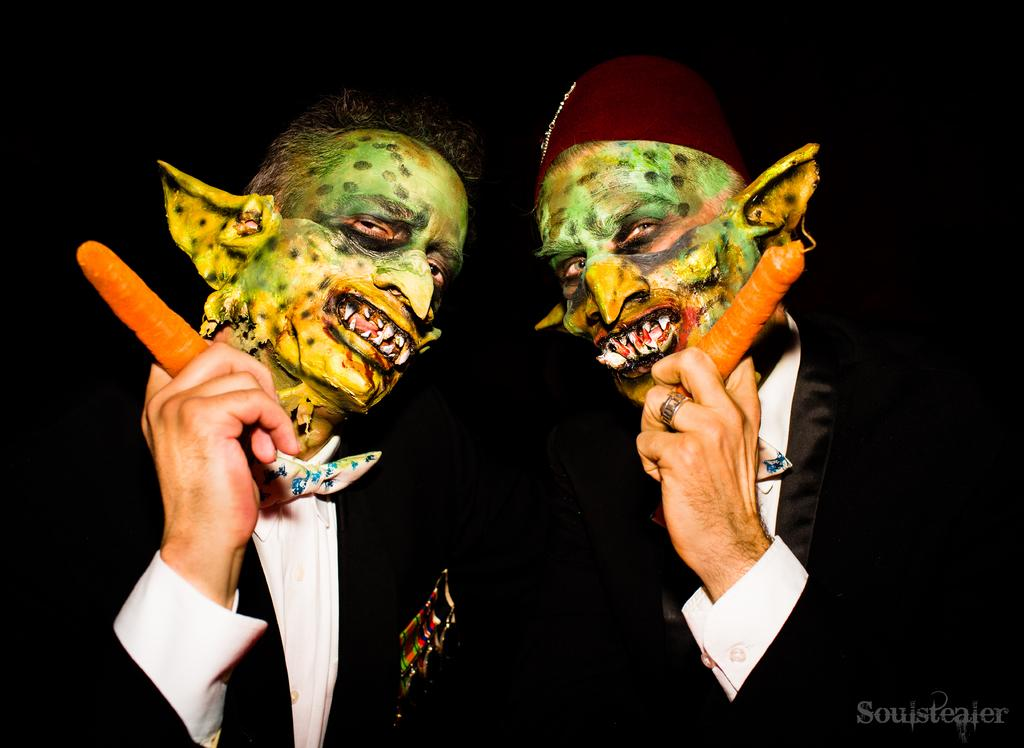How many people are in the image? There are two people in the image. What is unique about the appearance of the people in the image? The people have painted their faces as monsters. What type of clothing are the people wearing? The people are wearing formal suits. What are the people holding in their hands? The people are holding carrots in their hands. What color is the bucket in the room where the people are standing? There is no bucket or room mentioned in the image; it only features two people with painted monster faces, wearing formal suits, and holding carrots. 